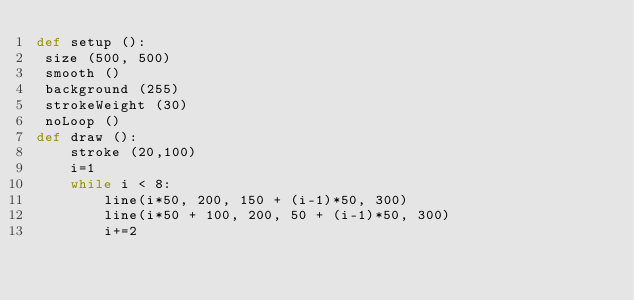Convert code to text. <code><loc_0><loc_0><loc_500><loc_500><_Python_>def setup ():
 size (500, 500)
 smooth ()
 background (255)
 strokeWeight (30)
 noLoop ()
def draw ():
    stroke (20,100)
    i=1
    while i < 8:
        line(i*50, 200, 150 + (i-1)*50, 300)
        line(i*50 + 100, 200, 50 + (i-1)*50, 300)
        i+=2
</code> 